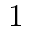Convert formula to latex. <formula><loc_0><loc_0><loc_500><loc_500>1</formula> 